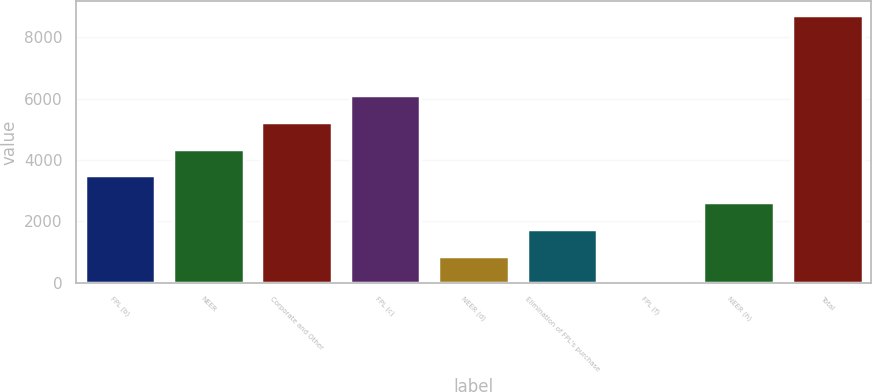Convert chart. <chart><loc_0><loc_0><loc_500><loc_500><bar_chart><fcel>FPL (b)<fcel>NEER<fcel>Corporate and Other<fcel>FPL (c)<fcel>NEER (d)<fcel>Elimination of FPL's purchase<fcel>FPL (f)<fcel>NEER (h)<fcel>Total<nl><fcel>3498<fcel>4372<fcel>5246<fcel>6120<fcel>876<fcel>1750<fcel>2<fcel>2624<fcel>8742<nl></chart> 